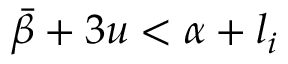<formula> <loc_0><loc_0><loc_500><loc_500>\bar { \beta } + 3 u < \alpha + l _ { i }</formula> 